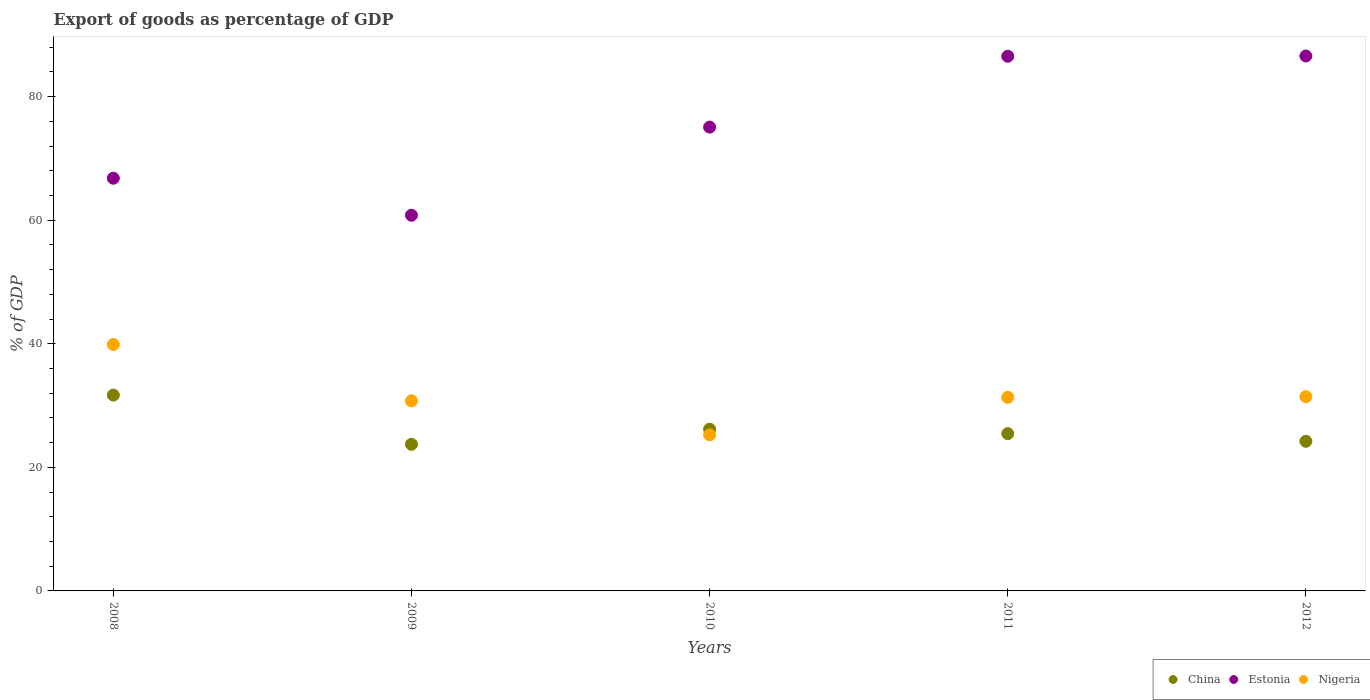What is the export of goods as percentage of GDP in Nigeria in 2010?
Give a very brief answer. 25.26. Across all years, what is the maximum export of goods as percentage of GDP in Estonia?
Your response must be concise. 86.58. Across all years, what is the minimum export of goods as percentage of GDP in Nigeria?
Keep it short and to the point. 25.26. In which year was the export of goods as percentage of GDP in China maximum?
Give a very brief answer. 2008. What is the total export of goods as percentage of GDP in China in the graph?
Give a very brief answer. 131.28. What is the difference between the export of goods as percentage of GDP in China in 2009 and that in 2012?
Your answer should be very brief. -0.49. What is the difference between the export of goods as percentage of GDP in Nigeria in 2009 and the export of goods as percentage of GDP in China in 2012?
Give a very brief answer. 6.55. What is the average export of goods as percentage of GDP in Estonia per year?
Offer a very short reply. 75.16. In the year 2009, what is the difference between the export of goods as percentage of GDP in Estonia and export of goods as percentage of GDP in Nigeria?
Your response must be concise. 30.04. In how many years, is the export of goods as percentage of GDP in Nigeria greater than 24 %?
Provide a succinct answer. 5. What is the ratio of the export of goods as percentage of GDP in China in 2008 to that in 2009?
Provide a short and direct response. 1.34. What is the difference between the highest and the second highest export of goods as percentage of GDP in Estonia?
Provide a short and direct response. 0.04. What is the difference between the highest and the lowest export of goods as percentage of GDP in Estonia?
Offer a terse response. 25.78. Is the sum of the export of goods as percentage of GDP in Nigeria in 2009 and 2010 greater than the maximum export of goods as percentage of GDP in Estonia across all years?
Provide a succinct answer. No. Is it the case that in every year, the sum of the export of goods as percentage of GDP in China and export of goods as percentage of GDP in Estonia  is greater than the export of goods as percentage of GDP in Nigeria?
Offer a terse response. Yes. Does the export of goods as percentage of GDP in China monotonically increase over the years?
Keep it short and to the point. No. Is the export of goods as percentage of GDP in Estonia strictly greater than the export of goods as percentage of GDP in China over the years?
Offer a terse response. Yes. How many dotlines are there?
Keep it short and to the point. 3. How many years are there in the graph?
Provide a short and direct response. 5. Are the values on the major ticks of Y-axis written in scientific E-notation?
Your answer should be very brief. No. Does the graph contain grids?
Give a very brief answer. No. Where does the legend appear in the graph?
Keep it short and to the point. Bottom right. How many legend labels are there?
Make the answer very short. 3. What is the title of the graph?
Keep it short and to the point. Export of goods as percentage of GDP. Does "World" appear as one of the legend labels in the graph?
Keep it short and to the point. No. What is the label or title of the Y-axis?
Make the answer very short. % of GDP. What is the % of GDP of China in 2008?
Your answer should be compact. 31.7. What is the % of GDP of Estonia in 2008?
Your answer should be compact. 66.8. What is the % of GDP of Nigeria in 2008?
Offer a very short reply. 39.88. What is the % of GDP of China in 2009?
Provide a short and direct response. 23.73. What is the % of GDP of Estonia in 2009?
Give a very brief answer. 60.8. What is the % of GDP of Nigeria in 2009?
Provide a short and direct response. 30.77. What is the % of GDP in China in 2010?
Make the answer very short. 26.17. What is the % of GDP in Estonia in 2010?
Your response must be concise. 75.07. What is the % of GDP of Nigeria in 2010?
Ensure brevity in your answer.  25.26. What is the % of GDP of China in 2011?
Keep it short and to the point. 25.46. What is the % of GDP of Estonia in 2011?
Ensure brevity in your answer.  86.54. What is the % of GDP in Nigeria in 2011?
Offer a very short reply. 31.33. What is the % of GDP in China in 2012?
Your answer should be compact. 24.22. What is the % of GDP of Estonia in 2012?
Ensure brevity in your answer.  86.58. What is the % of GDP in Nigeria in 2012?
Provide a succinct answer. 31.44. Across all years, what is the maximum % of GDP in China?
Your response must be concise. 31.7. Across all years, what is the maximum % of GDP of Estonia?
Your answer should be very brief. 86.58. Across all years, what is the maximum % of GDP of Nigeria?
Offer a very short reply. 39.88. Across all years, what is the minimum % of GDP of China?
Give a very brief answer. 23.73. Across all years, what is the minimum % of GDP of Estonia?
Your answer should be very brief. 60.8. Across all years, what is the minimum % of GDP of Nigeria?
Your answer should be compact. 25.26. What is the total % of GDP in China in the graph?
Ensure brevity in your answer.  131.28. What is the total % of GDP of Estonia in the graph?
Your response must be concise. 375.79. What is the total % of GDP in Nigeria in the graph?
Your response must be concise. 158.68. What is the difference between the % of GDP in China in 2008 and that in 2009?
Provide a succinct answer. 7.96. What is the difference between the % of GDP in Estonia in 2008 and that in 2009?
Make the answer very short. 5.99. What is the difference between the % of GDP in Nigeria in 2008 and that in 2009?
Give a very brief answer. 9.11. What is the difference between the % of GDP of China in 2008 and that in 2010?
Keep it short and to the point. 5.52. What is the difference between the % of GDP in Estonia in 2008 and that in 2010?
Your answer should be compact. -8.27. What is the difference between the % of GDP in Nigeria in 2008 and that in 2010?
Give a very brief answer. 14.62. What is the difference between the % of GDP in China in 2008 and that in 2011?
Offer a very short reply. 6.24. What is the difference between the % of GDP of Estonia in 2008 and that in 2011?
Ensure brevity in your answer.  -19.74. What is the difference between the % of GDP in Nigeria in 2008 and that in 2011?
Ensure brevity in your answer.  8.55. What is the difference between the % of GDP in China in 2008 and that in 2012?
Keep it short and to the point. 7.48. What is the difference between the % of GDP of Estonia in 2008 and that in 2012?
Make the answer very short. -19.78. What is the difference between the % of GDP of Nigeria in 2008 and that in 2012?
Ensure brevity in your answer.  8.44. What is the difference between the % of GDP of China in 2009 and that in 2010?
Keep it short and to the point. -2.44. What is the difference between the % of GDP of Estonia in 2009 and that in 2010?
Make the answer very short. -14.26. What is the difference between the % of GDP in Nigeria in 2009 and that in 2010?
Keep it short and to the point. 5.5. What is the difference between the % of GDP in China in 2009 and that in 2011?
Keep it short and to the point. -1.72. What is the difference between the % of GDP in Estonia in 2009 and that in 2011?
Your answer should be very brief. -25.73. What is the difference between the % of GDP in Nigeria in 2009 and that in 2011?
Provide a succinct answer. -0.56. What is the difference between the % of GDP of China in 2009 and that in 2012?
Your response must be concise. -0.49. What is the difference between the % of GDP in Estonia in 2009 and that in 2012?
Ensure brevity in your answer.  -25.78. What is the difference between the % of GDP in Nigeria in 2009 and that in 2012?
Your answer should be compact. -0.67. What is the difference between the % of GDP of China in 2010 and that in 2011?
Make the answer very short. 0.72. What is the difference between the % of GDP in Estonia in 2010 and that in 2011?
Give a very brief answer. -11.47. What is the difference between the % of GDP of Nigeria in 2010 and that in 2011?
Provide a succinct answer. -6.07. What is the difference between the % of GDP in China in 2010 and that in 2012?
Your response must be concise. 1.95. What is the difference between the % of GDP in Estonia in 2010 and that in 2012?
Your response must be concise. -11.51. What is the difference between the % of GDP in Nigeria in 2010 and that in 2012?
Offer a very short reply. -6.17. What is the difference between the % of GDP of China in 2011 and that in 2012?
Give a very brief answer. 1.24. What is the difference between the % of GDP of Estonia in 2011 and that in 2012?
Your response must be concise. -0.04. What is the difference between the % of GDP of Nigeria in 2011 and that in 2012?
Keep it short and to the point. -0.11. What is the difference between the % of GDP in China in 2008 and the % of GDP in Estonia in 2009?
Keep it short and to the point. -29.11. What is the difference between the % of GDP of China in 2008 and the % of GDP of Nigeria in 2009?
Provide a succinct answer. 0.93. What is the difference between the % of GDP in Estonia in 2008 and the % of GDP in Nigeria in 2009?
Ensure brevity in your answer.  36.03. What is the difference between the % of GDP in China in 2008 and the % of GDP in Estonia in 2010?
Offer a very short reply. -43.37. What is the difference between the % of GDP in China in 2008 and the % of GDP in Nigeria in 2010?
Provide a succinct answer. 6.43. What is the difference between the % of GDP in Estonia in 2008 and the % of GDP in Nigeria in 2010?
Give a very brief answer. 41.53. What is the difference between the % of GDP in China in 2008 and the % of GDP in Estonia in 2011?
Offer a very short reply. -54.84. What is the difference between the % of GDP in China in 2008 and the % of GDP in Nigeria in 2011?
Provide a short and direct response. 0.37. What is the difference between the % of GDP of Estonia in 2008 and the % of GDP of Nigeria in 2011?
Your answer should be very brief. 35.47. What is the difference between the % of GDP in China in 2008 and the % of GDP in Estonia in 2012?
Your answer should be very brief. -54.89. What is the difference between the % of GDP in China in 2008 and the % of GDP in Nigeria in 2012?
Offer a very short reply. 0.26. What is the difference between the % of GDP in Estonia in 2008 and the % of GDP in Nigeria in 2012?
Keep it short and to the point. 35.36. What is the difference between the % of GDP of China in 2009 and the % of GDP of Estonia in 2010?
Provide a short and direct response. -51.33. What is the difference between the % of GDP of China in 2009 and the % of GDP of Nigeria in 2010?
Your response must be concise. -1.53. What is the difference between the % of GDP of Estonia in 2009 and the % of GDP of Nigeria in 2010?
Your answer should be compact. 35.54. What is the difference between the % of GDP of China in 2009 and the % of GDP of Estonia in 2011?
Provide a succinct answer. -62.81. What is the difference between the % of GDP of China in 2009 and the % of GDP of Nigeria in 2011?
Keep it short and to the point. -7.6. What is the difference between the % of GDP of Estonia in 2009 and the % of GDP of Nigeria in 2011?
Keep it short and to the point. 29.47. What is the difference between the % of GDP in China in 2009 and the % of GDP in Estonia in 2012?
Offer a terse response. -62.85. What is the difference between the % of GDP in China in 2009 and the % of GDP in Nigeria in 2012?
Provide a succinct answer. -7.71. What is the difference between the % of GDP in Estonia in 2009 and the % of GDP in Nigeria in 2012?
Your answer should be very brief. 29.37. What is the difference between the % of GDP of China in 2010 and the % of GDP of Estonia in 2011?
Provide a short and direct response. -60.37. What is the difference between the % of GDP in China in 2010 and the % of GDP in Nigeria in 2011?
Give a very brief answer. -5.16. What is the difference between the % of GDP of Estonia in 2010 and the % of GDP of Nigeria in 2011?
Provide a succinct answer. 43.74. What is the difference between the % of GDP of China in 2010 and the % of GDP of Estonia in 2012?
Give a very brief answer. -60.41. What is the difference between the % of GDP in China in 2010 and the % of GDP in Nigeria in 2012?
Provide a succinct answer. -5.27. What is the difference between the % of GDP of Estonia in 2010 and the % of GDP of Nigeria in 2012?
Your answer should be very brief. 43.63. What is the difference between the % of GDP of China in 2011 and the % of GDP of Estonia in 2012?
Your answer should be compact. -61.13. What is the difference between the % of GDP in China in 2011 and the % of GDP in Nigeria in 2012?
Offer a terse response. -5.98. What is the difference between the % of GDP in Estonia in 2011 and the % of GDP in Nigeria in 2012?
Your response must be concise. 55.1. What is the average % of GDP in China per year?
Make the answer very short. 26.26. What is the average % of GDP of Estonia per year?
Provide a short and direct response. 75.16. What is the average % of GDP of Nigeria per year?
Your answer should be very brief. 31.74. In the year 2008, what is the difference between the % of GDP of China and % of GDP of Estonia?
Make the answer very short. -35.1. In the year 2008, what is the difference between the % of GDP in China and % of GDP in Nigeria?
Provide a short and direct response. -8.19. In the year 2008, what is the difference between the % of GDP of Estonia and % of GDP of Nigeria?
Your answer should be very brief. 26.91. In the year 2009, what is the difference between the % of GDP of China and % of GDP of Estonia?
Give a very brief answer. -37.07. In the year 2009, what is the difference between the % of GDP in China and % of GDP in Nigeria?
Offer a terse response. -7.04. In the year 2009, what is the difference between the % of GDP in Estonia and % of GDP in Nigeria?
Provide a short and direct response. 30.04. In the year 2010, what is the difference between the % of GDP in China and % of GDP in Estonia?
Provide a succinct answer. -48.9. In the year 2010, what is the difference between the % of GDP in China and % of GDP in Nigeria?
Your response must be concise. 0.91. In the year 2010, what is the difference between the % of GDP of Estonia and % of GDP of Nigeria?
Give a very brief answer. 49.8. In the year 2011, what is the difference between the % of GDP of China and % of GDP of Estonia?
Your response must be concise. -61.08. In the year 2011, what is the difference between the % of GDP in China and % of GDP in Nigeria?
Provide a succinct answer. -5.87. In the year 2011, what is the difference between the % of GDP in Estonia and % of GDP in Nigeria?
Give a very brief answer. 55.21. In the year 2012, what is the difference between the % of GDP in China and % of GDP in Estonia?
Make the answer very short. -62.36. In the year 2012, what is the difference between the % of GDP of China and % of GDP of Nigeria?
Ensure brevity in your answer.  -7.22. In the year 2012, what is the difference between the % of GDP in Estonia and % of GDP in Nigeria?
Ensure brevity in your answer.  55.14. What is the ratio of the % of GDP in China in 2008 to that in 2009?
Your response must be concise. 1.34. What is the ratio of the % of GDP of Estonia in 2008 to that in 2009?
Your answer should be compact. 1.1. What is the ratio of the % of GDP in Nigeria in 2008 to that in 2009?
Your answer should be very brief. 1.3. What is the ratio of the % of GDP of China in 2008 to that in 2010?
Keep it short and to the point. 1.21. What is the ratio of the % of GDP of Estonia in 2008 to that in 2010?
Your answer should be compact. 0.89. What is the ratio of the % of GDP in Nigeria in 2008 to that in 2010?
Your answer should be very brief. 1.58. What is the ratio of the % of GDP in China in 2008 to that in 2011?
Offer a terse response. 1.25. What is the ratio of the % of GDP of Estonia in 2008 to that in 2011?
Ensure brevity in your answer.  0.77. What is the ratio of the % of GDP of Nigeria in 2008 to that in 2011?
Keep it short and to the point. 1.27. What is the ratio of the % of GDP of China in 2008 to that in 2012?
Provide a succinct answer. 1.31. What is the ratio of the % of GDP of Estonia in 2008 to that in 2012?
Make the answer very short. 0.77. What is the ratio of the % of GDP in Nigeria in 2008 to that in 2012?
Provide a succinct answer. 1.27. What is the ratio of the % of GDP in China in 2009 to that in 2010?
Offer a very short reply. 0.91. What is the ratio of the % of GDP of Estonia in 2009 to that in 2010?
Your answer should be compact. 0.81. What is the ratio of the % of GDP in Nigeria in 2009 to that in 2010?
Provide a short and direct response. 1.22. What is the ratio of the % of GDP of China in 2009 to that in 2011?
Offer a terse response. 0.93. What is the ratio of the % of GDP in Estonia in 2009 to that in 2011?
Make the answer very short. 0.7. What is the ratio of the % of GDP in Nigeria in 2009 to that in 2011?
Make the answer very short. 0.98. What is the ratio of the % of GDP in Estonia in 2009 to that in 2012?
Keep it short and to the point. 0.7. What is the ratio of the % of GDP in Nigeria in 2009 to that in 2012?
Your answer should be compact. 0.98. What is the ratio of the % of GDP in China in 2010 to that in 2011?
Make the answer very short. 1.03. What is the ratio of the % of GDP of Estonia in 2010 to that in 2011?
Make the answer very short. 0.87. What is the ratio of the % of GDP in Nigeria in 2010 to that in 2011?
Keep it short and to the point. 0.81. What is the ratio of the % of GDP in China in 2010 to that in 2012?
Provide a short and direct response. 1.08. What is the ratio of the % of GDP of Estonia in 2010 to that in 2012?
Make the answer very short. 0.87. What is the ratio of the % of GDP in Nigeria in 2010 to that in 2012?
Provide a short and direct response. 0.8. What is the ratio of the % of GDP in China in 2011 to that in 2012?
Keep it short and to the point. 1.05. What is the ratio of the % of GDP in Nigeria in 2011 to that in 2012?
Your response must be concise. 1. What is the difference between the highest and the second highest % of GDP in China?
Your response must be concise. 5.52. What is the difference between the highest and the second highest % of GDP in Estonia?
Offer a terse response. 0.04. What is the difference between the highest and the second highest % of GDP of Nigeria?
Offer a very short reply. 8.44. What is the difference between the highest and the lowest % of GDP in China?
Provide a succinct answer. 7.96. What is the difference between the highest and the lowest % of GDP of Estonia?
Offer a very short reply. 25.78. What is the difference between the highest and the lowest % of GDP of Nigeria?
Make the answer very short. 14.62. 